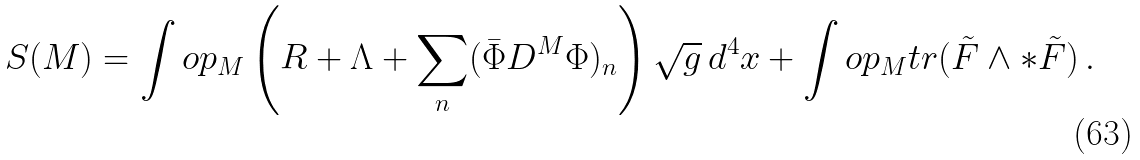<formula> <loc_0><loc_0><loc_500><loc_500>S ( M ) = \int o p _ { M } \left ( R + \Lambda + \sum _ { n } ( \bar { \Phi } D ^ { M } \Phi ) _ { n } \right ) \sqrt { g } \, d ^ { 4 } x + \int o p _ { M } t r ( \tilde { F } \wedge * \tilde { F } ) \, .</formula> 